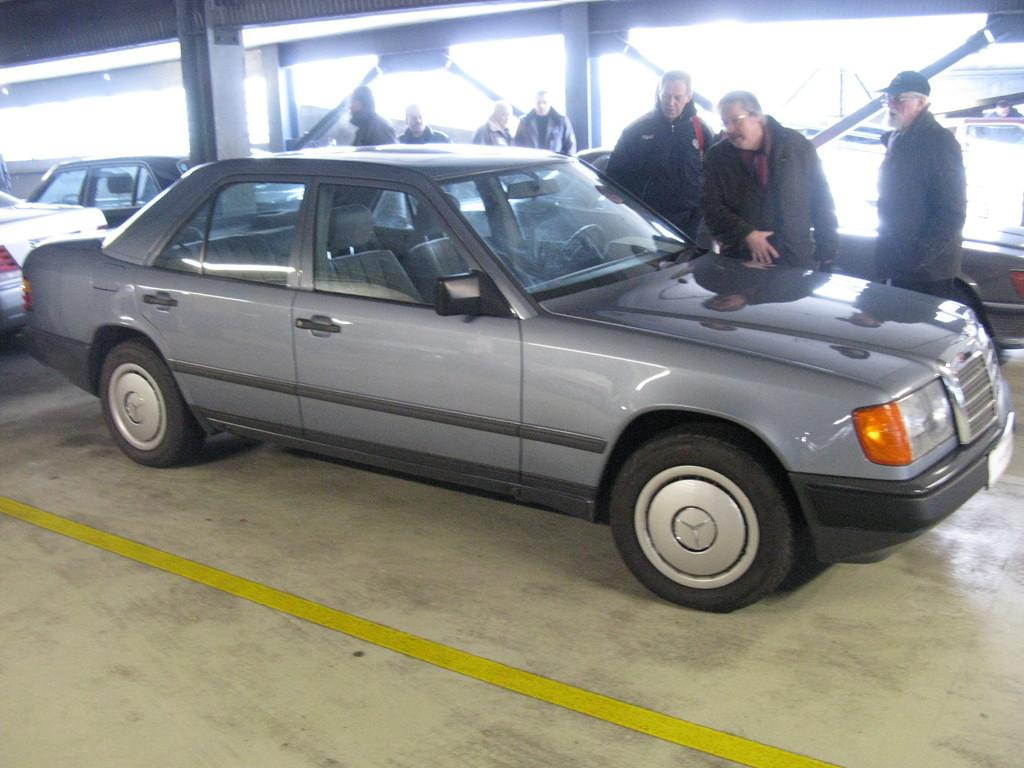Who or what can be seen in the image? There are people in the image. What else is present in the image besides people? There are vehicles in the image. Can you describe the ground in the image? The ground is visible in the image. What else can be seen in the image that is related to structures or infrastructure? There are poles in the image. What part of a building is visible in the image? The roof is visible in the image. What time of day is it in the image, specifically in the afternoon? The time of day is not mentioned in the image, and there is no indication of the afternoon. 